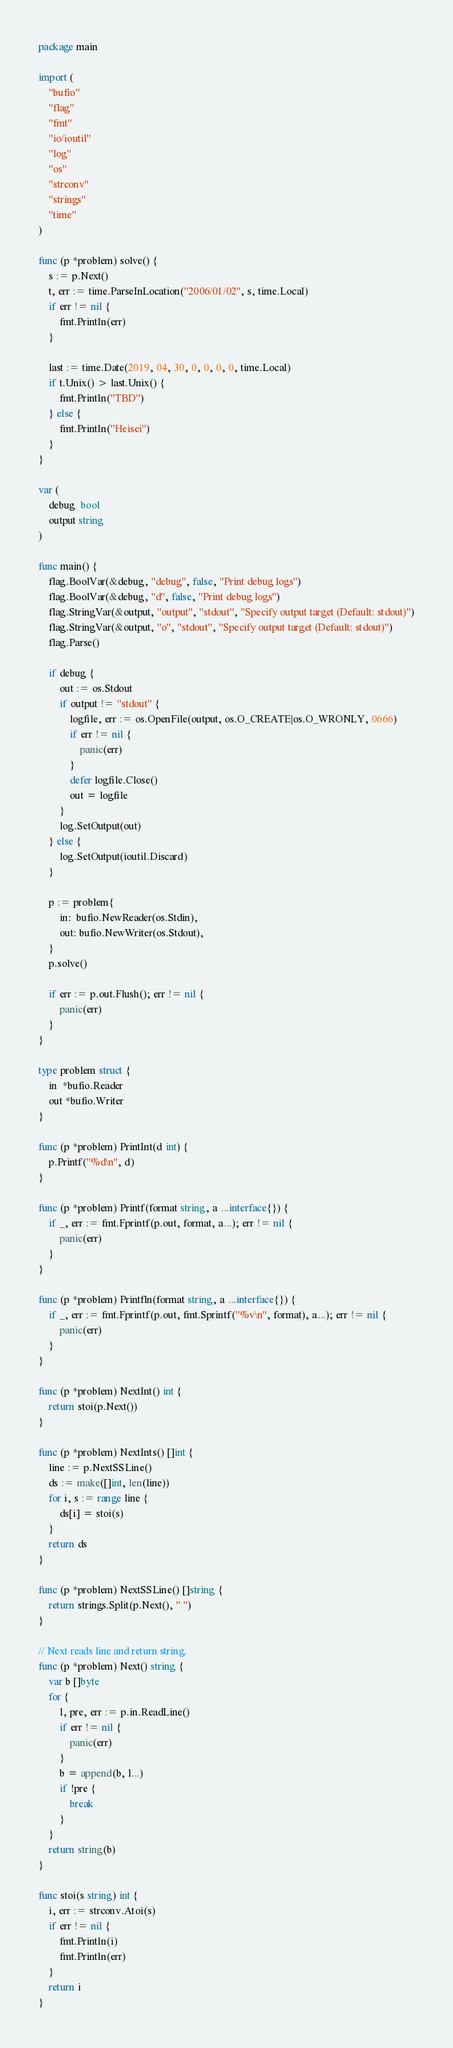<code> <loc_0><loc_0><loc_500><loc_500><_Go_>package main

import (
	"bufio"
	"flag"
	"fmt"
	"io/ioutil"
	"log"
	"os"
	"strconv"
	"strings"
	"time"
)

func (p *problem) solve() {
	s := p.Next()
	t, err := time.ParseInLocation("2006/01/02", s, time.Local)
	if err != nil {
		fmt.Println(err)
	}

	last := time.Date(2019, 04, 30, 0, 0, 0, 0, time.Local)
	if t.Unix() > last.Unix() {
		fmt.Println("TBD")
	} else {
		fmt.Println("Heisei")
	}
}

var (
	debug  bool
	output string
)

func main() {
	flag.BoolVar(&debug, "debug", false, "Print debug logs")
	flag.BoolVar(&debug, "d", false, "Print debug logs")
	flag.StringVar(&output, "output", "stdout", "Specify output target (Default: stdout)")
	flag.StringVar(&output, "o", "stdout", "Specify output target (Default: stdout)")
	flag.Parse()

	if debug {
		out := os.Stdout
		if output != "stdout" {
			logfile, err := os.OpenFile(output, os.O_CREATE|os.O_WRONLY, 0666)
			if err != nil {
				panic(err)
			}
			defer logfile.Close()
			out = logfile
		}
		log.SetOutput(out)
	} else {
		log.SetOutput(ioutil.Discard)
	}

	p := problem{
		in:  bufio.NewReader(os.Stdin),
		out: bufio.NewWriter(os.Stdout),
	}
	p.solve()

	if err := p.out.Flush(); err != nil {
		panic(err)
	}
}

type problem struct {
	in  *bufio.Reader
	out *bufio.Writer
}

func (p *problem) PrintInt(d int) {
	p.Printf("%d\n", d)
}

func (p *problem) Printf(format string, a ...interface{}) {
	if _, err := fmt.Fprintf(p.out, format, a...); err != nil {
		panic(err)
	}
}

func (p *problem) Printfln(format string, a ...interface{}) {
	if _, err := fmt.Fprintf(p.out, fmt.Sprintf("%v\n", format), a...); err != nil {
		panic(err)
	}
}

func (p *problem) NextInt() int {
	return stoi(p.Next())
}

func (p *problem) NextInts() []int {
	line := p.NextSSLine()
	ds := make([]int, len(line))
	for i, s := range line {
		ds[i] = stoi(s)
	}
	return ds
}

func (p *problem) NextSSLine() []string {
	return strings.Split(p.Next(), " ")
}

// Next reads line and return string.
func (p *problem) Next() string {
	var b []byte
	for {
		l, pre, err := p.in.ReadLine()
		if err != nil {
			panic(err)
		}
		b = append(b, l...)
		if !pre {
			break
		}
	}
	return string(b)
}

func stoi(s string) int {
	i, err := strconv.Atoi(s)
	if err != nil {
		fmt.Println(i)
		fmt.Println(err)
	}
	return i
}
</code> 